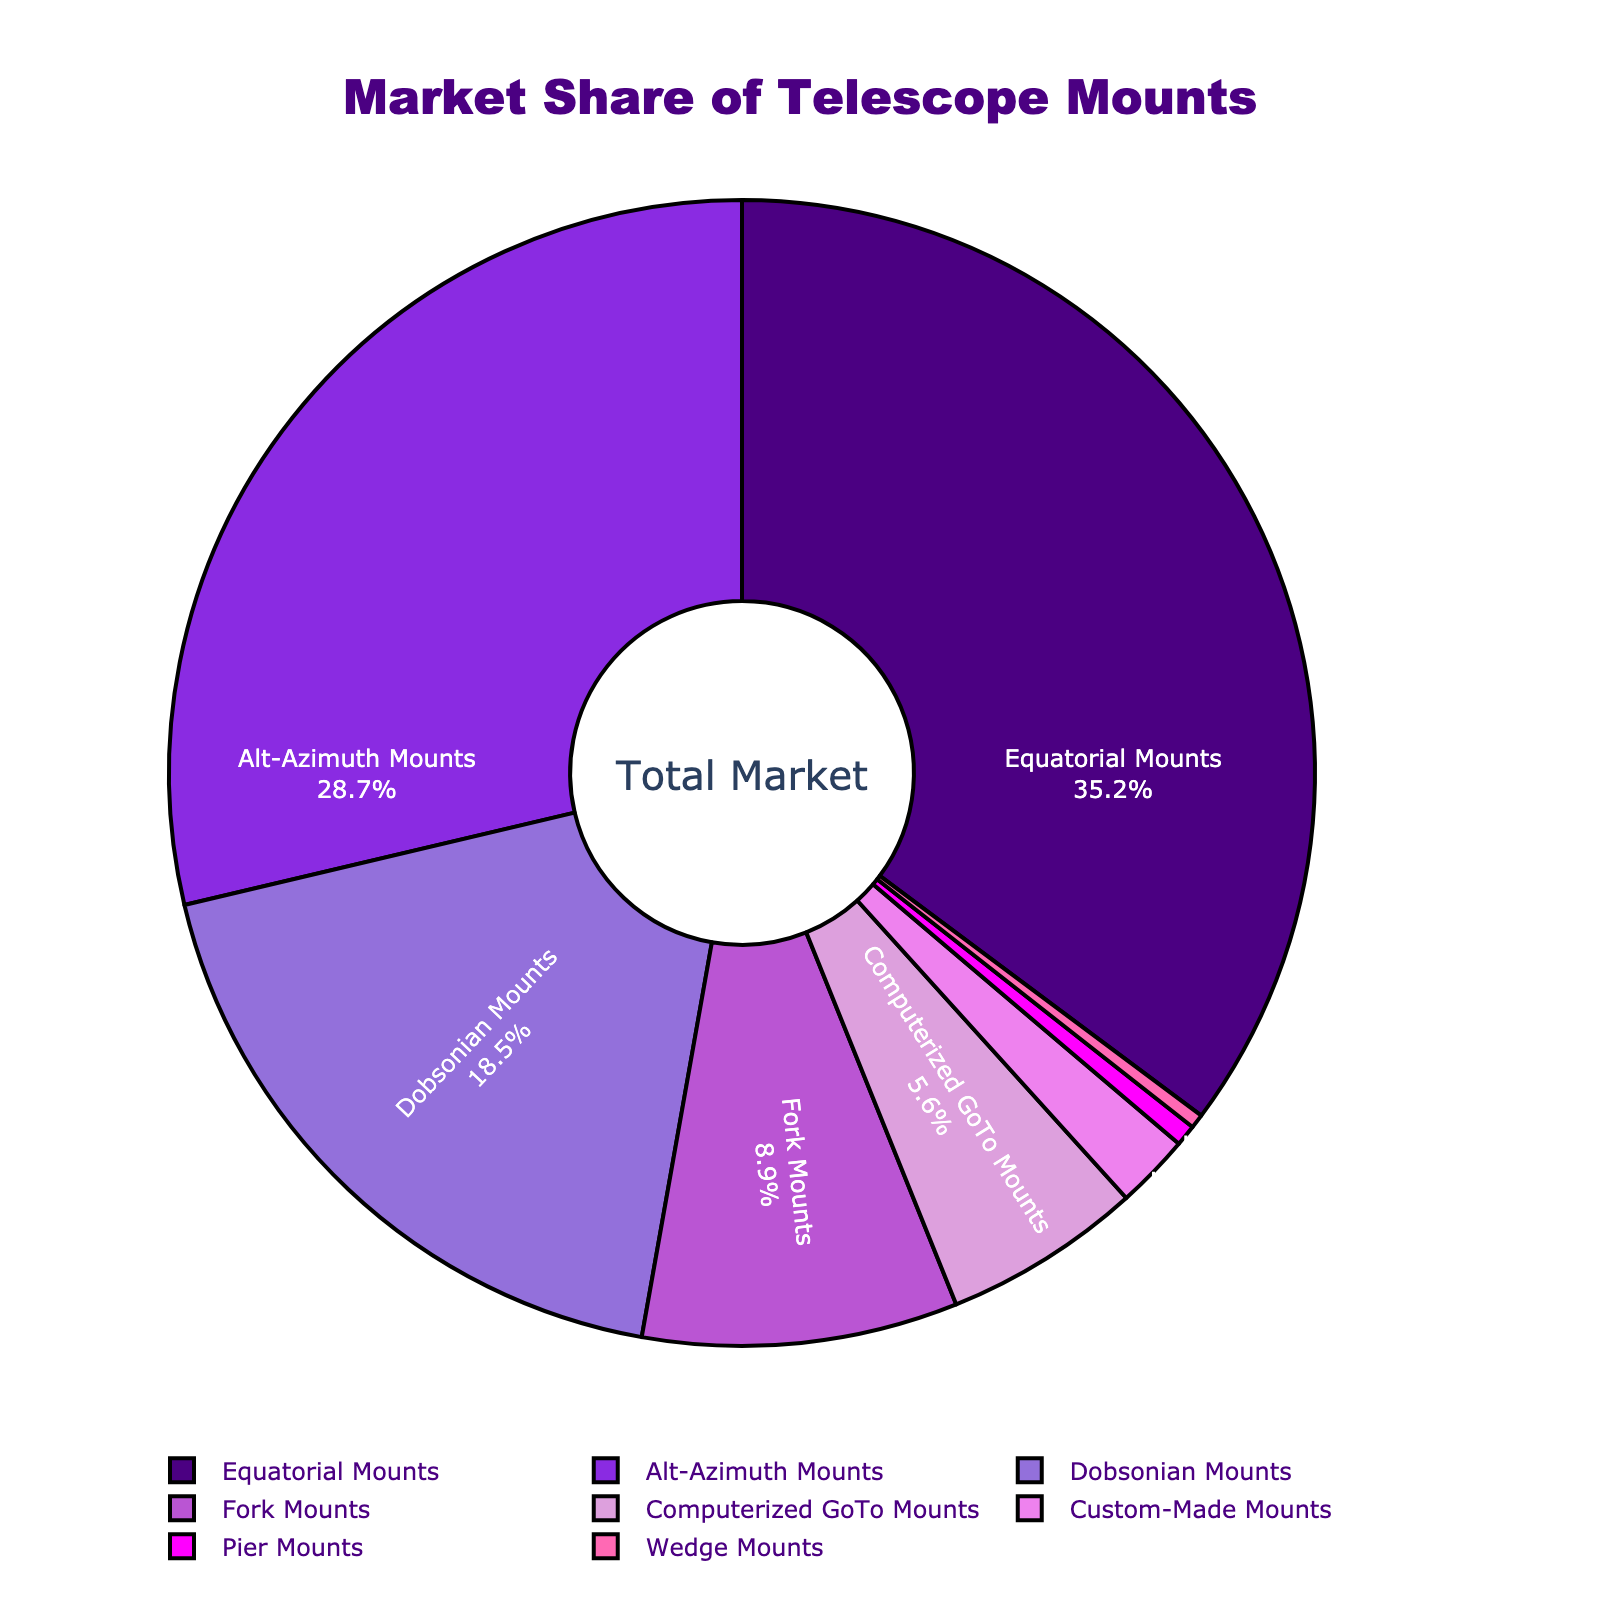What type of telescope mount has the largest market share? By looking at the pie chart, the largest section will represent the type with the largest market share.
Answer: Equatorial Mounts What is the combined market share of Dobsonian Mounts and Computerized GoTo Mounts? Add the market shares of Dobsonian Mounts (18.5%) and Computerized GoTo Mounts (5.6%).
Answer: 24.1% Which telescope mount type has a smaller market share: Fork Mounts or Custom-Made Mounts? Compare the market share percentages: Fork Mounts (8.9%) vs. Custom-Made Mounts (2.1%).
Answer: Custom-Made Mounts What is the difference in market share between Equatorial Mounts and Alt-Azimuth Mounts? Subtract the market share of Alt-Azimuth Mounts (28.7%) from that of Equatorial Mounts (35.2%).
Answer: 6.5% What is the market share of mounts other than Equatorial and Alt-Azimuth Mounts combined? Sum the market shares of the mounts other than Equatorial and Alt-Azimuth Mounts: 18.5% + 8.9% + 5.6% + 2.1% + 0.6% + 0.4%.
Answer: 36.1% Which section of the pie chart appears in pink? Identify the color representation of the different types of mounts and match the pink color with "Fork Mounts".
Answer: Fork Mounts What is the total market share of mount types that have a market share below 5%? Sum the market shares of types below 5%: Custom-Made Mounts (2.1%), Pier Mounts (0.6%), Wedge Mounts (0.4%).
Answer: 3.1% Rank the top three telescope mount types by market share. Order the types by their market share percentages: Equatorial Mounts (35.2%), Alt-Azimuth Mounts (28.7%), and Dobsonian Mounts (18.5%).
Answer: Equatorial Mounts, Alt-Azimuth Mounts, Dobsonian Mounts What is the largest market share segment colored in, relative to the entire pie chart? Examine the colors and match the segment representing the largest market share, which is Equatorial Mounts.
Answer: Indigo 